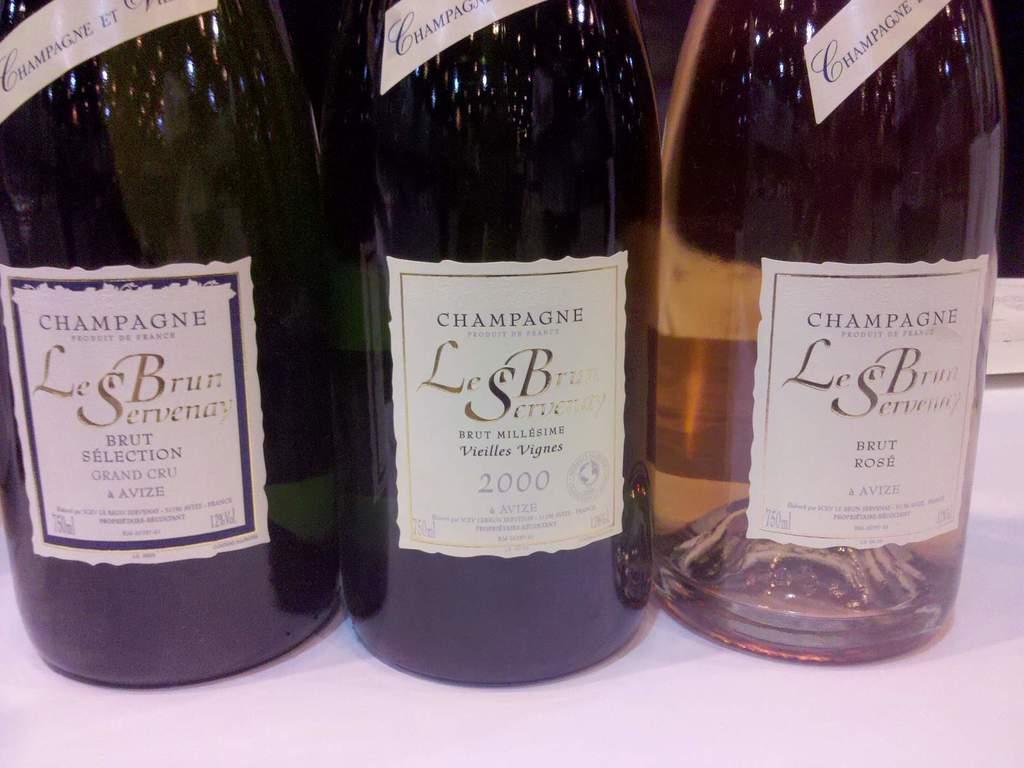What brand of champagne is this?
Offer a terse response. Le brun servenay. 